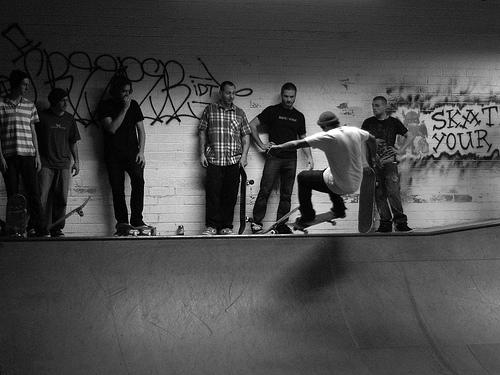Is there any females?
Keep it brief. No. Is the skateboarder wearing a hat?
Short answer required. Yes. What does the wall say on the far left?
Quick response, please. Idt. Is this skater going to make it?
Keep it brief. Yes. Is there a reflection in the image?
Keep it brief. No. How many people are watching the skateboarder?
Quick response, please. 6. Is this a modern photograph?
Keep it brief. Yes. Is this a wine tasting?
Write a very short answer. No. 